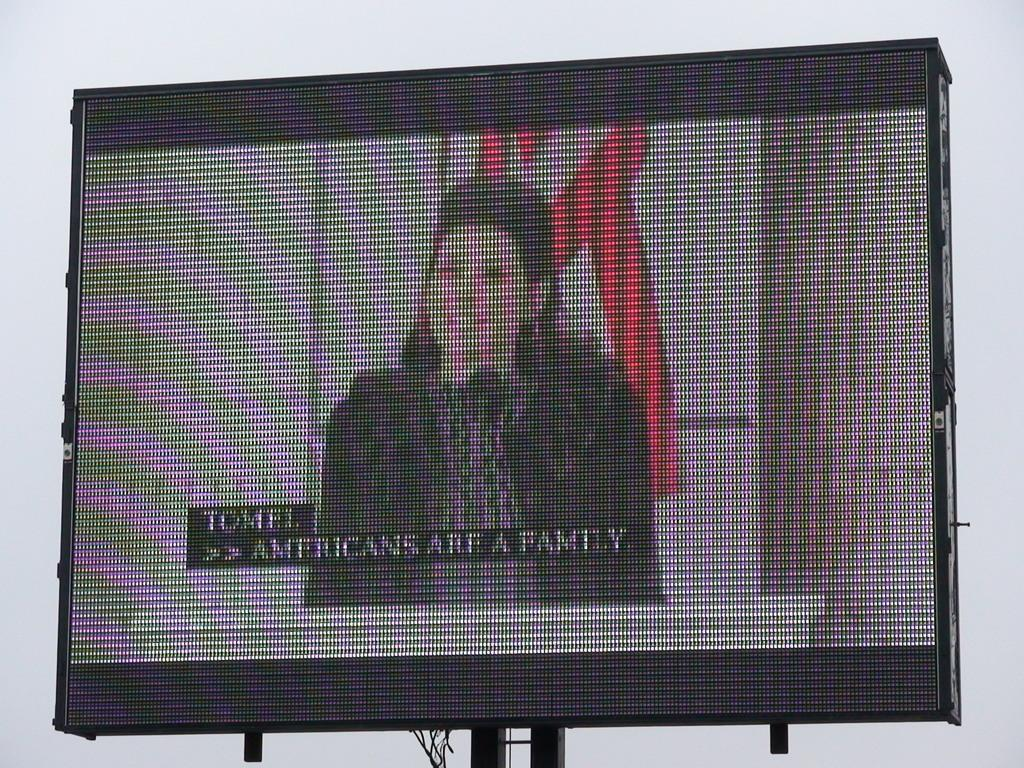What is the main object in the image? There is a screen in the image. What is the woman doing in the image? The woman is speaking in the image. Where is the woman positioned in the image? The woman is standing at a podium in the image. What is the woman using to amplify her voice? The woman is using a microphone in the image. Can you see the woman's friend walking on a trail in the image? There is no reference to a friend or a trail in the image; it features a woman speaking at a podium with a microphone and a screen. 